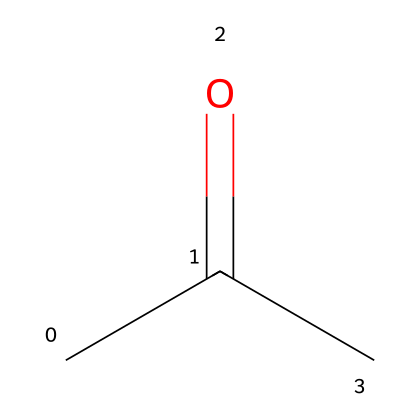What is the name of this chemical? The chemical structure depicted corresponds to acetone, known as a common industrial solvent. The presence of the carbonyl (C=O) group and the arrangement of carbon atoms indicates this.
Answer: acetone How many carbon atoms are in this molecule? Looking at the SMILES representation, "CC(=O)C," there are three distinct carbon atoms represented. Therefore, the count is three.
Answer: three What type of functional group is present in acetone? Acetone has a carbonyl functional group (C=O) which is characteristic of ketones. The positioning and bonding of the carbon atoms indicate this functional group.
Answer: carbonyl How many hydrogen atoms are in acetone? Analyzing the structure, for each carbon atom, the hydrogen count can be determined based on the carbon's valency. The total number of hydrogens in acetone, calculated accordingly, equals six.
Answer: six Is acetone a polar or nonpolar solvent? Given the presence of the polar carbonyl group and the overall structure of acetone, it demonstrates characteristics of a polar solvent due to its ability to interact with polar substances.
Answer: polar What indicates that this compound is a ketone? The presence of a carbonyl group (C=O) flanked by two carbon atoms is a definitive structural characteristic of ketones, as seen in the given structure.
Answer: carbonyl group What is the molecular formula of acetone? By counting the constituent atoms based on the chemical structure, acetone has three carbon atoms, six hydrogen atoms, and one oxygen atom, resulting in the formula C3H6O.
Answer: C3H6O 